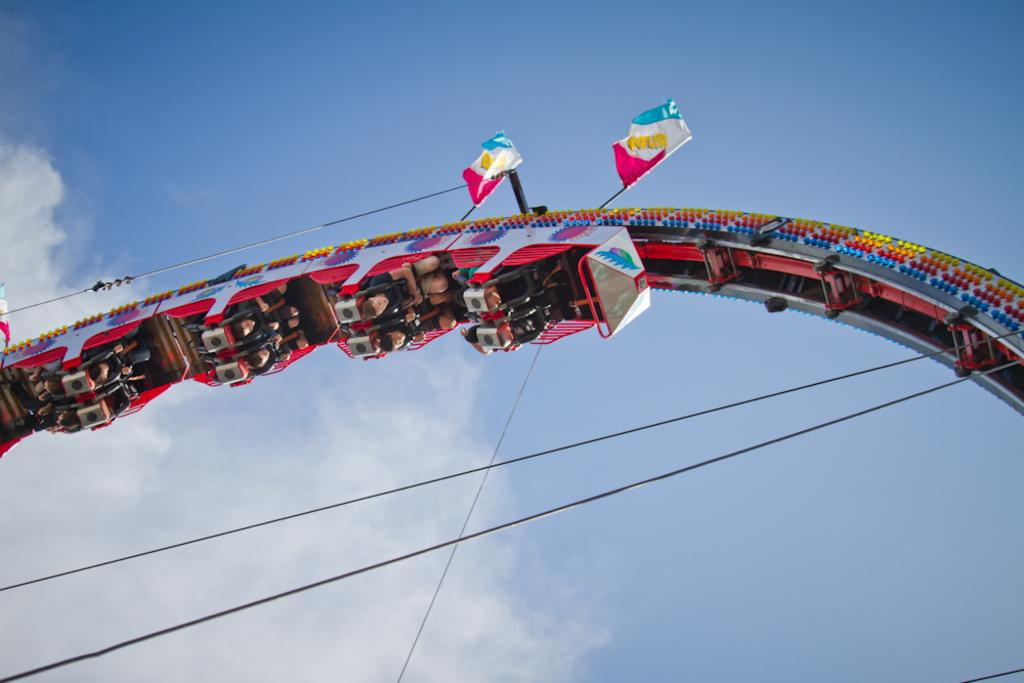What is the main subject of the image? The main subject of the image is a roller coaster. Can you describe the appearance of the roller coaster? The roller coaster is colorful. From where was the image taken? The image is taken from the ground. Are there any people in the image? Yes, some people are riding the roller coaster. What can be seen in the background of the image? The sky is visible in the background of the image. Can you tell me how many icicles are hanging from the roller coaster in the image? There are no icicles present in the image; it features a colorful roller coaster with people riding it. What type of guide is provided for the roller coaster in the image? There is no guide mentioned or visible in the image; it simply shows the roller coaster and people riding it. 